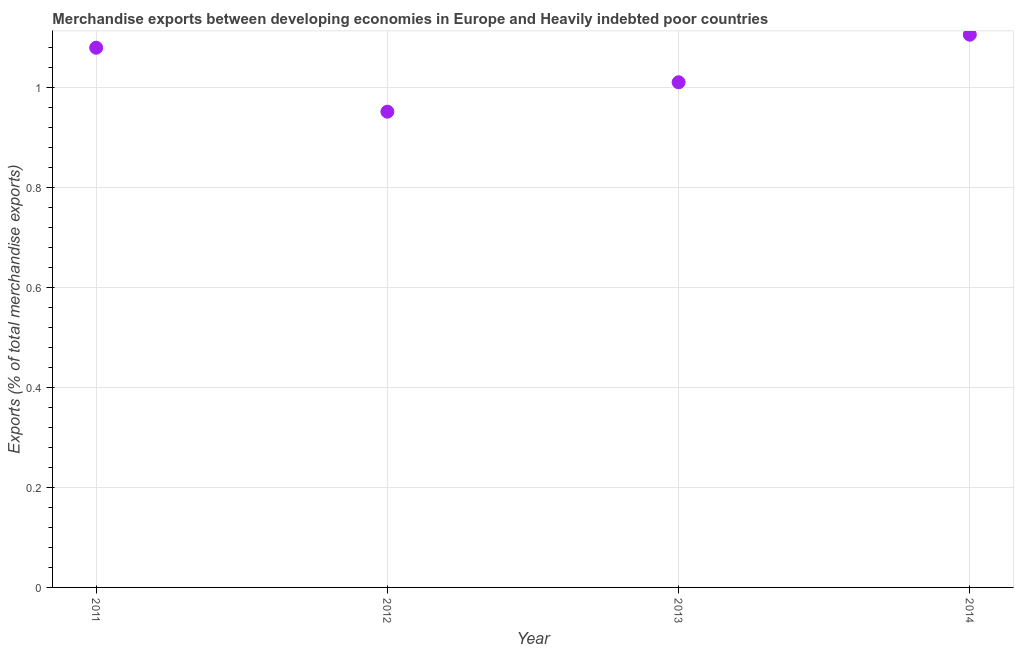What is the merchandise exports in 2013?
Provide a succinct answer. 1.01. Across all years, what is the maximum merchandise exports?
Your answer should be compact. 1.1. Across all years, what is the minimum merchandise exports?
Give a very brief answer. 0.95. In which year was the merchandise exports minimum?
Offer a very short reply. 2012. What is the sum of the merchandise exports?
Give a very brief answer. 4.14. What is the difference between the merchandise exports in 2011 and 2012?
Provide a short and direct response. 0.13. What is the average merchandise exports per year?
Offer a very short reply. 1.04. What is the median merchandise exports?
Keep it short and to the point. 1.04. Do a majority of the years between 2012 and 2014 (inclusive) have merchandise exports greater than 0.88 %?
Offer a very short reply. Yes. What is the ratio of the merchandise exports in 2012 to that in 2013?
Your answer should be compact. 0.94. Is the merchandise exports in 2013 less than that in 2014?
Offer a very short reply. Yes. What is the difference between the highest and the second highest merchandise exports?
Keep it short and to the point. 0.03. Is the sum of the merchandise exports in 2011 and 2012 greater than the maximum merchandise exports across all years?
Keep it short and to the point. Yes. What is the difference between the highest and the lowest merchandise exports?
Your answer should be very brief. 0.15. In how many years, is the merchandise exports greater than the average merchandise exports taken over all years?
Provide a succinct answer. 2. Does the merchandise exports monotonically increase over the years?
Your answer should be compact. No. How many years are there in the graph?
Provide a short and direct response. 4. What is the difference between two consecutive major ticks on the Y-axis?
Your answer should be very brief. 0.2. What is the title of the graph?
Ensure brevity in your answer.  Merchandise exports between developing economies in Europe and Heavily indebted poor countries. What is the label or title of the Y-axis?
Your answer should be compact. Exports (% of total merchandise exports). What is the Exports (% of total merchandise exports) in 2011?
Keep it short and to the point. 1.08. What is the Exports (% of total merchandise exports) in 2012?
Give a very brief answer. 0.95. What is the Exports (% of total merchandise exports) in 2013?
Ensure brevity in your answer.  1.01. What is the Exports (% of total merchandise exports) in 2014?
Provide a short and direct response. 1.1. What is the difference between the Exports (% of total merchandise exports) in 2011 and 2012?
Offer a very short reply. 0.13. What is the difference between the Exports (% of total merchandise exports) in 2011 and 2013?
Offer a very short reply. 0.07. What is the difference between the Exports (% of total merchandise exports) in 2011 and 2014?
Offer a very short reply. -0.03. What is the difference between the Exports (% of total merchandise exports) in 2012 and 2013?
Your answer should be compact. -0.06. What is the difference between the Exports (% of total merchandise exports) in 2012 and 2014?
Offer a terse response. -0.15. What is the difference between the Exports (% of total merchandise exports) in 2013 and 2014?
Provide a succinct answer. -0.1. What is the ratio of the Exports (% of total merchandise exports) in 2011 to that in 2012?
Ensure brevity in your answer.  1.13. What is the ratio of the Exports (% of total merchandise exports) in 2011 to that in 2013?
Offer a very short reply. 1.07. What is the ratio of the Exports (% of total merchandise exports) in 2011 to that in 2014?
Provide a succinct answer. 0.98. What is the ratio of the Exports (% of total merchandise exports) in 2012 to that in 2013?
Provide a succinct answer. 0.94. What is the ratio of the Exports (% of total merchandise exports) in 2012 to that in 2014?
Your answer should be compact. 0.86. What is the ratio of the Exports (% of total merchandise exports) in 2013 to that in 2014?
Your answer should be compact. 0.91. 